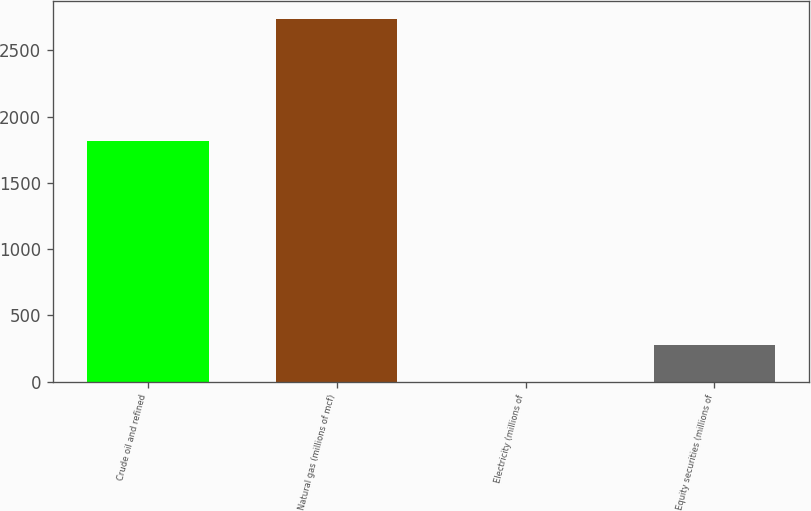<chart> <loc_0><loc_0><loc_500><loc_500><bar_chart><fcel>Crude oil and refined<fcel>Natural gas (millions of mcf)<fcel>Electricity (millions of<fcel>Equity securities (millions of<nl><fcel>1815<fcel>2735<fcel>1<fcel>274.4<nl></chart> 